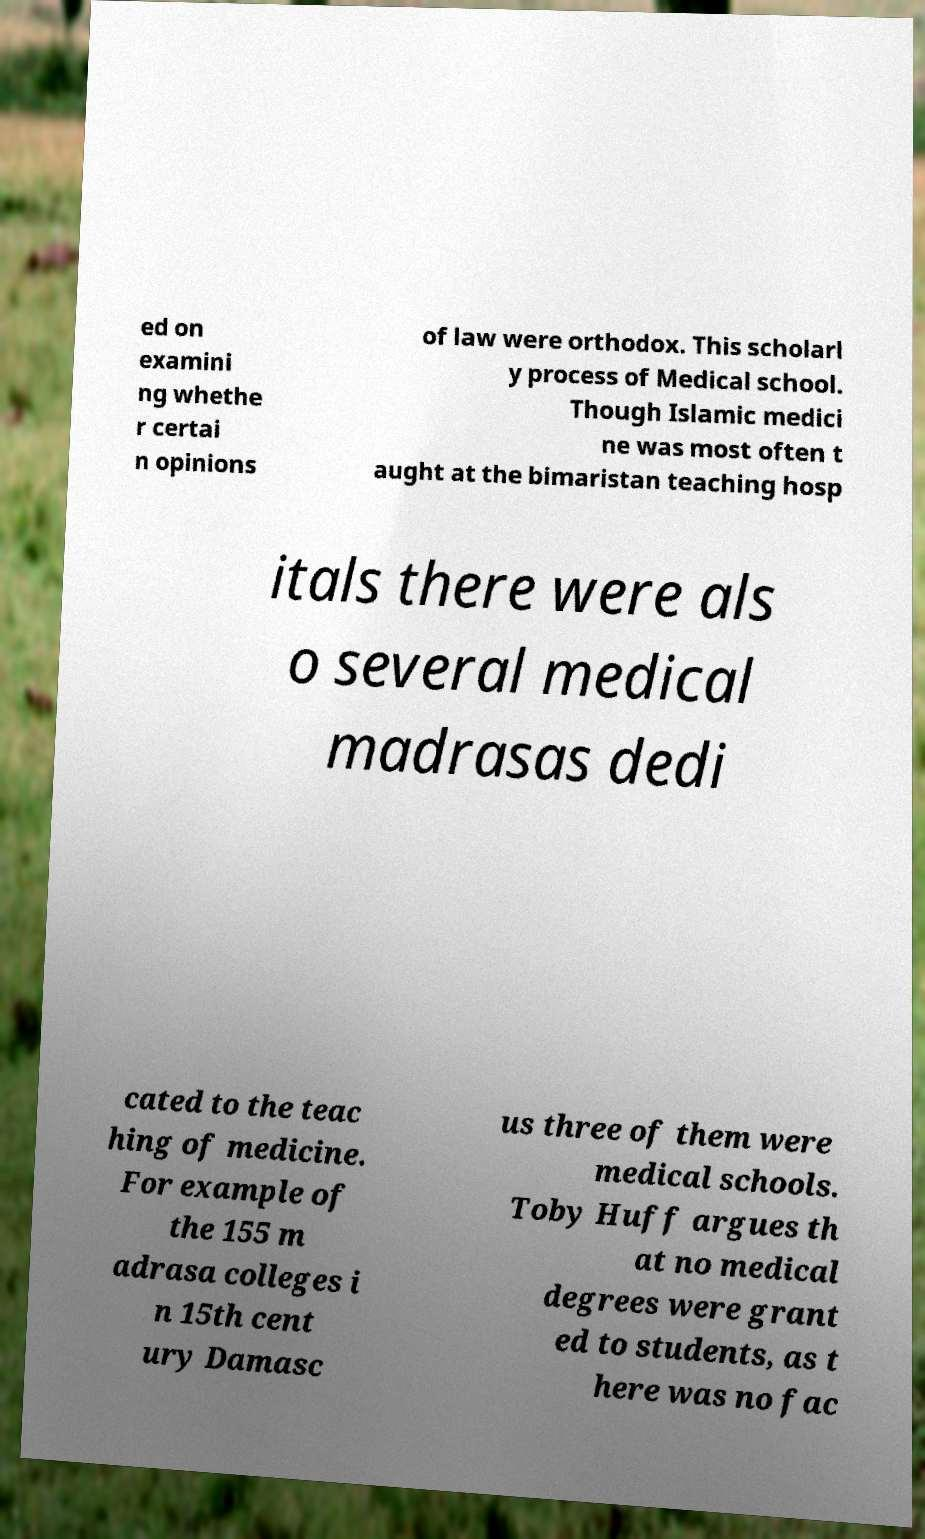Please read and relay the text visible in this image. What does it say? ed on examini ng whethe r certai n opinions of law were orthodox. This scholarl y process of Medical school. Though Islamic medici ne was most often t aught at the bimaristan teaching hosp itals there were als o several medical madrasas dedi cated to the teac hing of medicine. For example of the 155 m adrasa colleges i n 15th cent ury Damasc us three of them were medical schools. Toby Huff argues th at no medical degrees were grant ed to students, as t here was no fac 